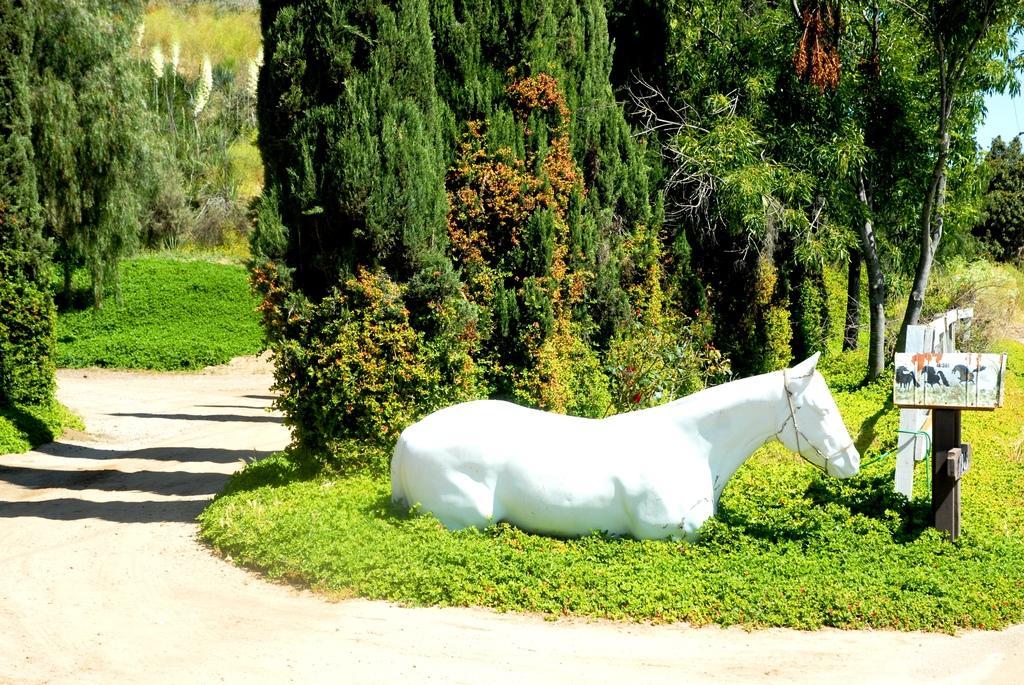Describe this image in one or two sentences. In this image we can see a statue. We can also see a signboard, fence, grass, a group of trees and the sky. 